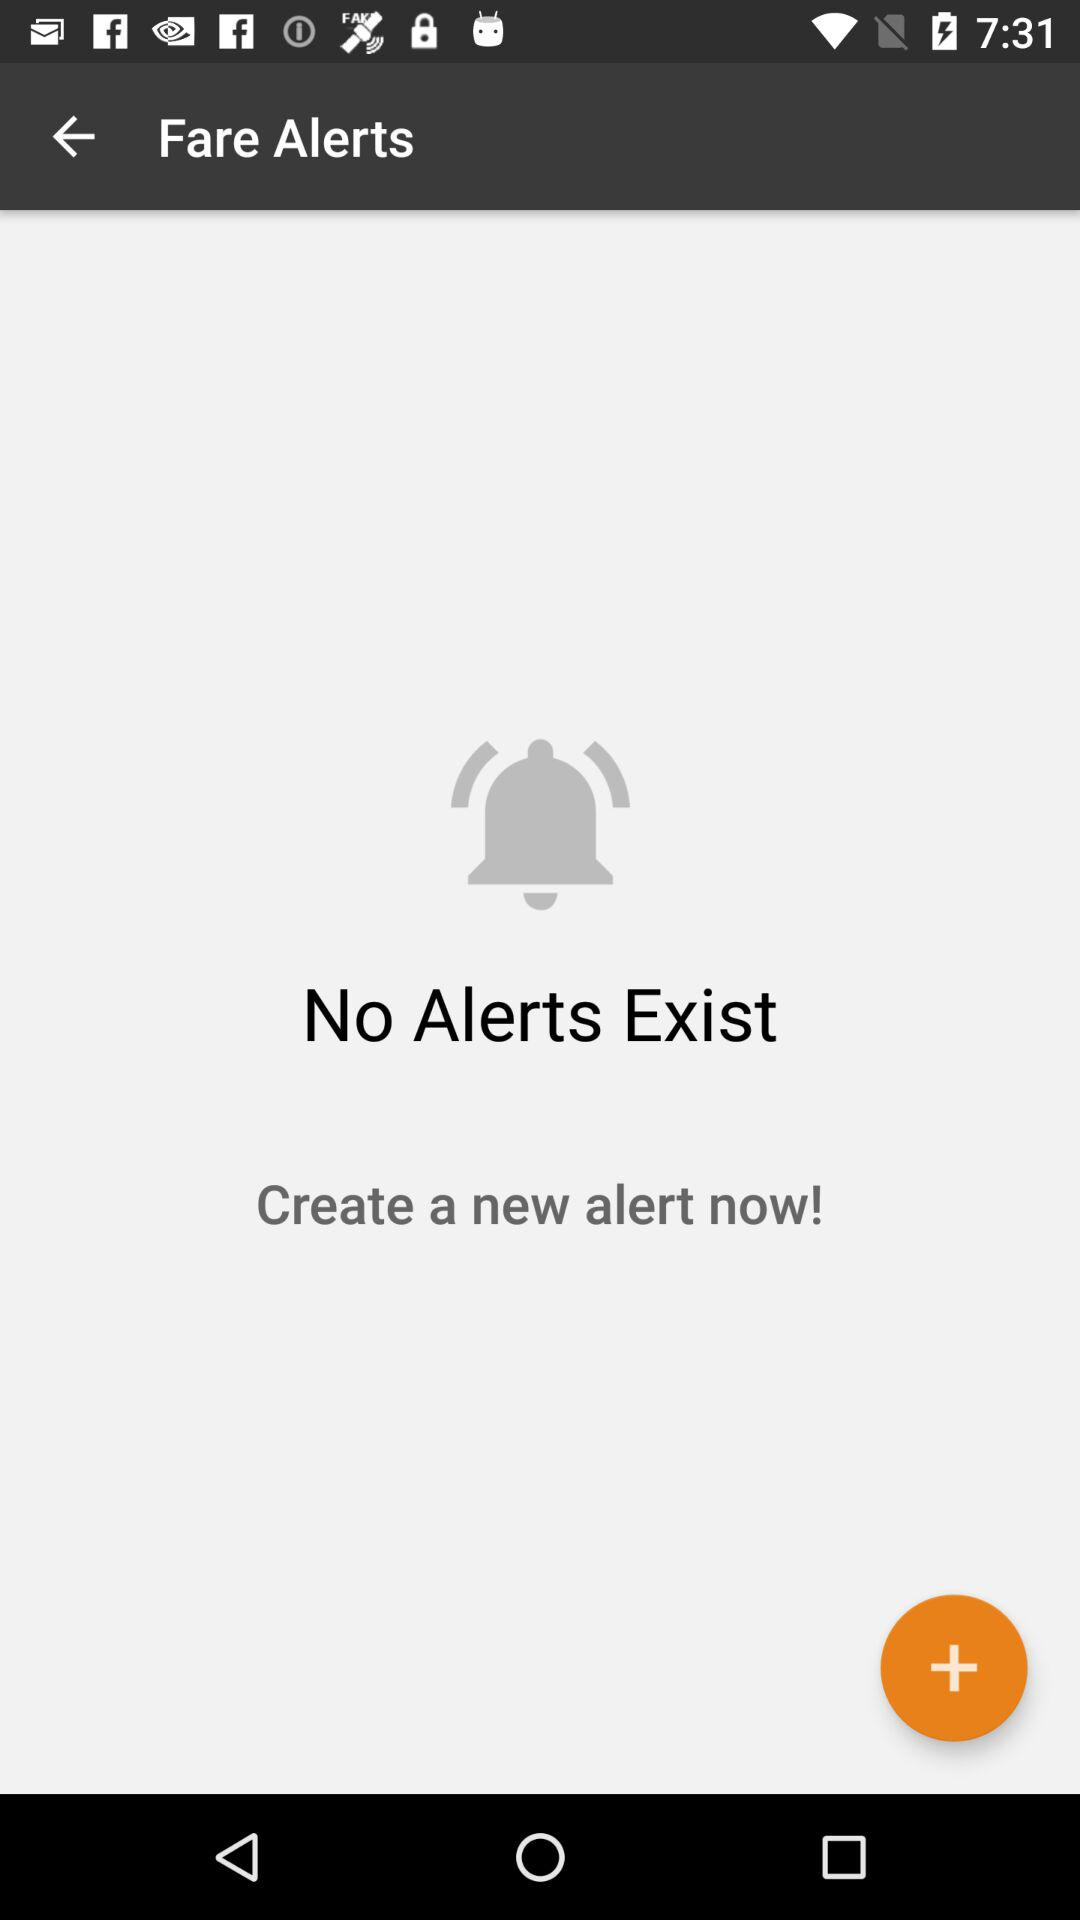Is there any alert? There is no alert. 